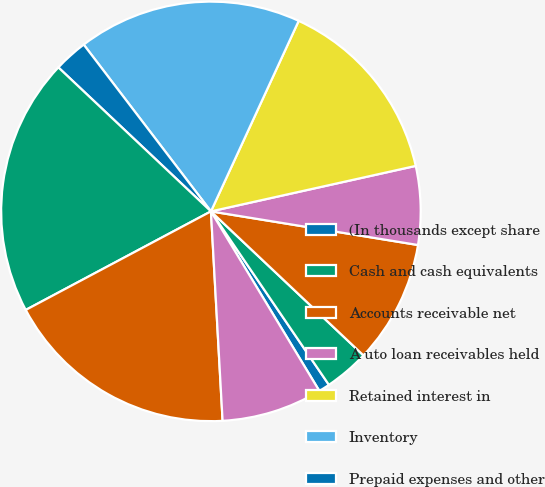Convert chart to OTSL. <chart><loc_0><loc_0><loc_500><loc_500><pie_chart><fcel>(In thousands except share<fcel>Cash and cash equivalents<fcel>Accounts receivable net<fcel>A uto loan receivables held<fcel>Retained interest in<fcel>Inventory<fcel>Prepaid expenses and other<fcel>TOTAL CURRENT ASSETS<fcel>Property and equipment net<fcel>Deferred income taxes<nl><fcel>0.86%<fcel>3.45%<fcel>9.48%<fcel>6.04%<fcel>14.65%<fcel>17.24%<fcel>2.59%<fcel>19.82%<fcel>18.1%<fcel>7.76%<nl></chart> 